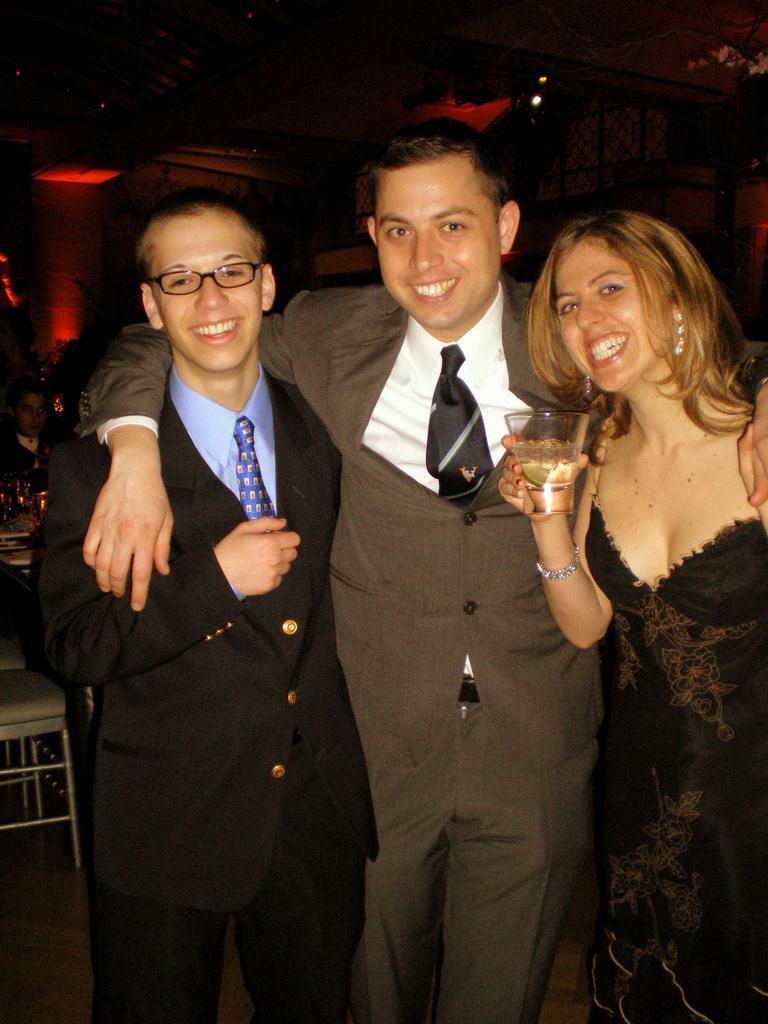Could you give a brief overview of what you see in this image? In this image we can see three people standing the lady standing on the right is holding a glass. In the background there is a wall and we can see lights. There are chairs and tables. 